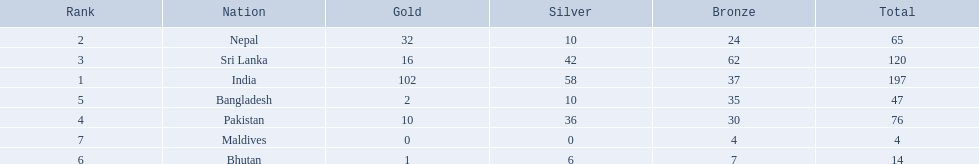What are the nations? India, Nepal, Sri Lanka, Pakistan, Bangladesh, Bhutan, Maldives. Of these, which one has earned the least amount of gold medals? Maldives. 